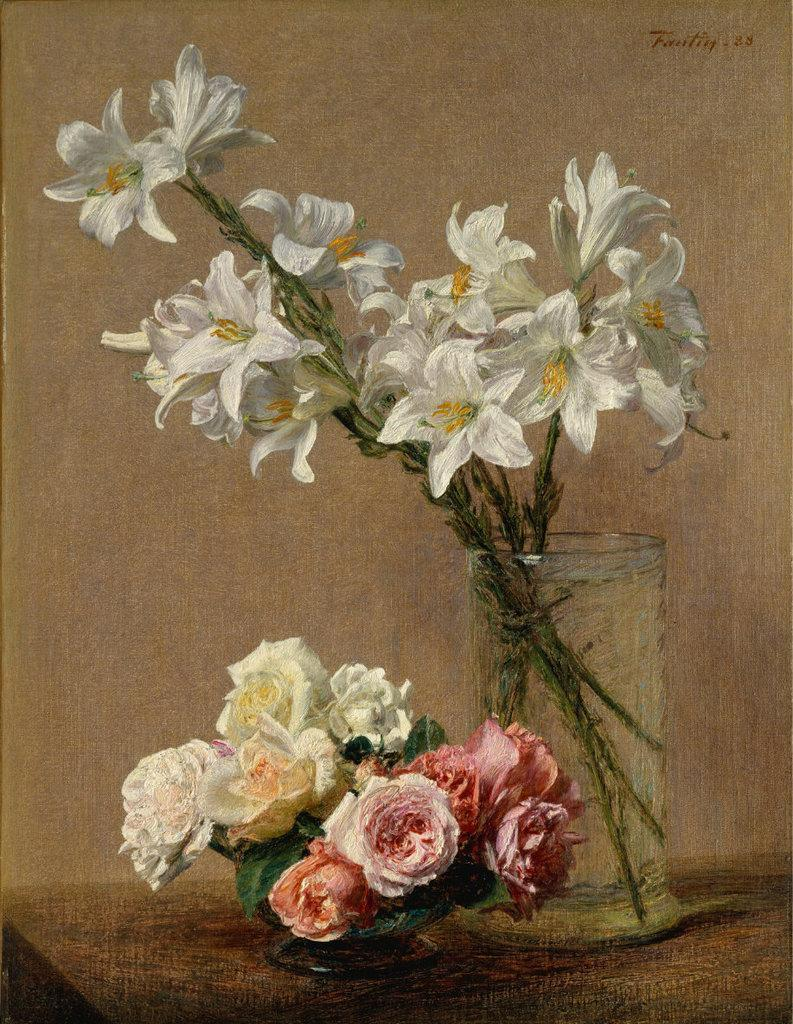What type of artwork is depicted in the image? The image is a painting. What objects are present in the painting? There are flowers in a vase and a bowl with flowers in the painting. Where is the bowl with flowers located in the painting? The bowl with flowers is placed on a table in the painting. What type of fuel is being used by the mice in the painting? There are no mice present in the painting, so there is no fuel being used by them. What degree of difficulty is depicted in the painting? The painting does not depict a degree of difficulty; it features flowers in a vase and a bowl with flowers on a table. 